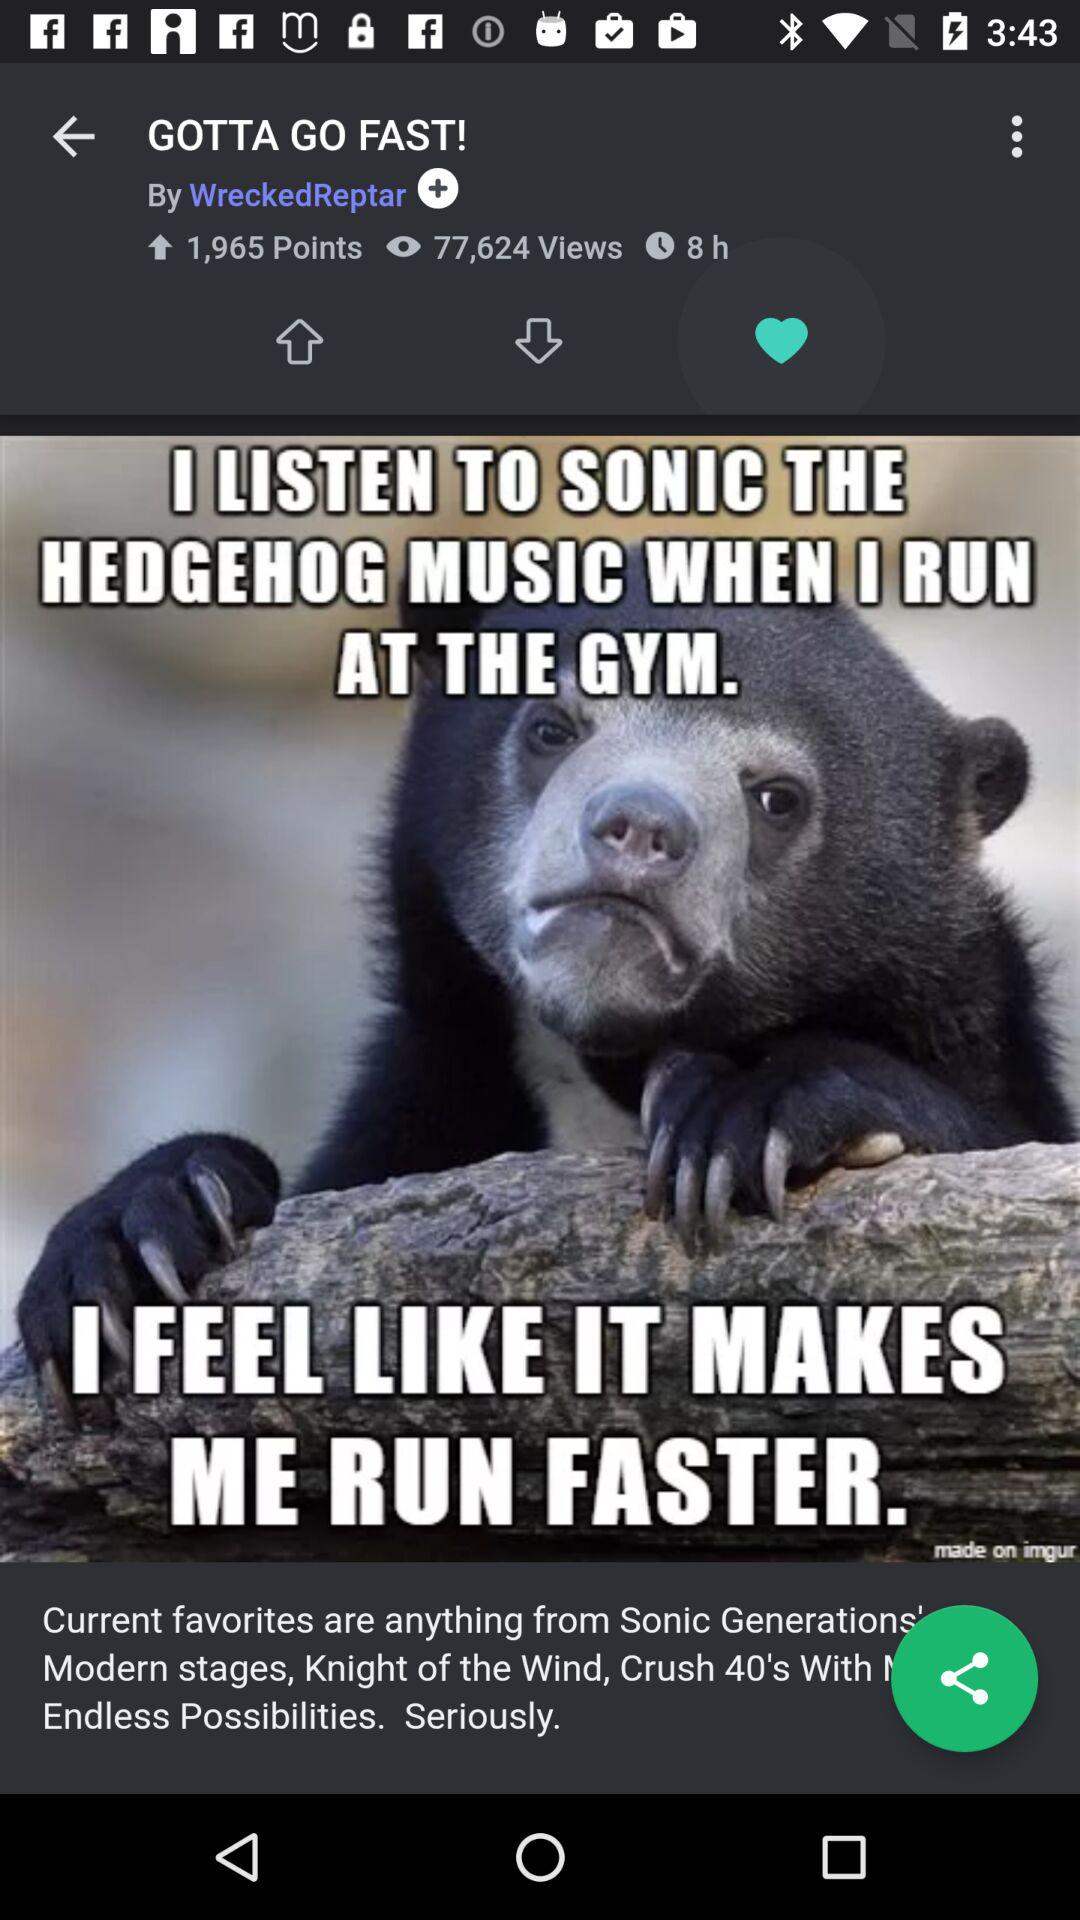How many points in total are there? There are 1,965 points. 